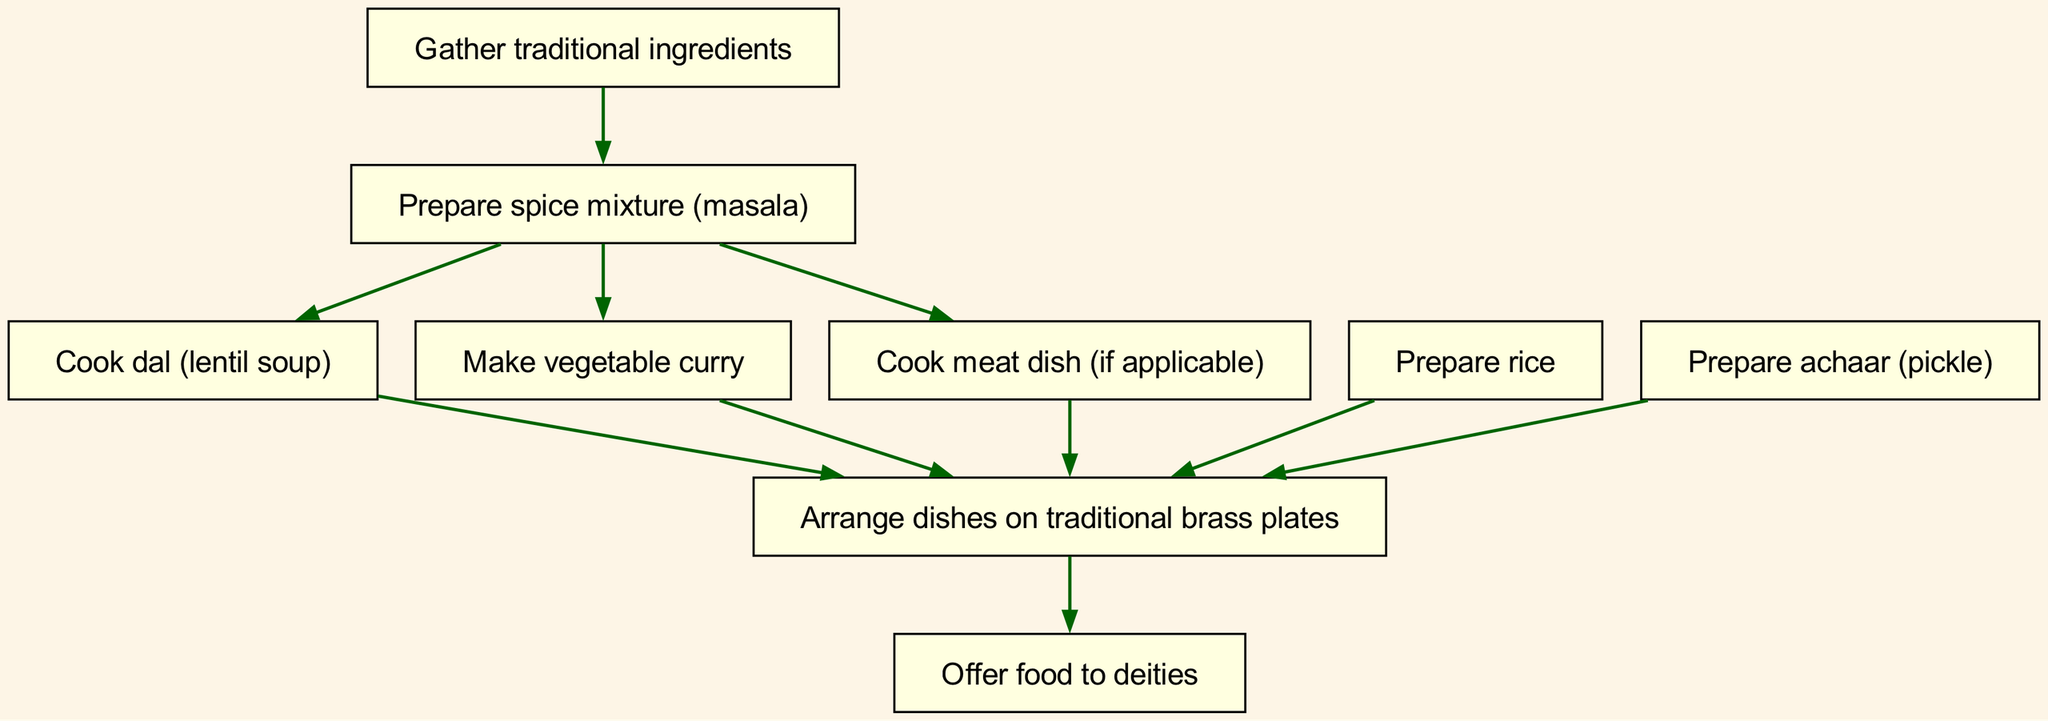What is the first step in preparing a typical Nepalese festival meal? The diagram shows that the first step (represented by the node "1") is "Gather traditional ingredients," which starts the flow of preparation.
Answer: Gather traditional ingredients How many steps are involved in this meal preparation process? By counting the nodes in the diagram, there are a total of nine steps, which represent the various tasks involved in preparing the meal.
Answer: Nine Which dish is prepared after making the spice mixture? According to the connections in the diagram, the spice mixture leads to the preparation of dal, vegetable curry, and meat dish, with dal being the first in sequence.
Answer: Cook dal What is the relationship between preparing rice and arranging dishes? The diagram shows that preparing rice is a prerequisite to arranging dishes, indicating that rice must be cooked before the dishes are arranged on traditional brass plates.
Answer: Preparing rice → Arrange dishes What is the last action taken in the process? The diagram indicates that the last action is to "Offer food to deities," which is the concluding step after arranging the dishes.
Answer: Offer food to deities How many dishes are prepared before arranging them on plates? The diagram shows that there are five dishes that lead to the arrangement on plates (dal, rice, vegetable curry, meat dish, and achaar).
Answer: Five Which dish does not have a direct connection to the preparation of rice? The diagram reveals that the connection from the spice mixture leads directly to preparing vegetable curry and meat dishes but does not connect directly to rice, indicating that the rice preparation is independent of that step.
Answer: Make vegetable curry What do you do after preparing achaar? The diagram indicates that after preparing achaar, the next step is arranging dishes on traditional brass plates, showing the flow of preparation.
Answer: Arrange dishes How does one obtain the spice mixture in the process? The diagram shows that the spice mixture is prepared after gathering the traditional ingredients, establishing the order of operations needed.
Answer: Gather traditional ingredients 